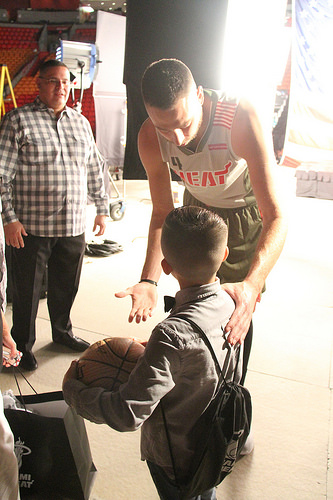<image>
Is there a man behind the boy? Yes. From this viewpoint, the man is positioned behind the boy, with the boy partially or fully occluding the man. 